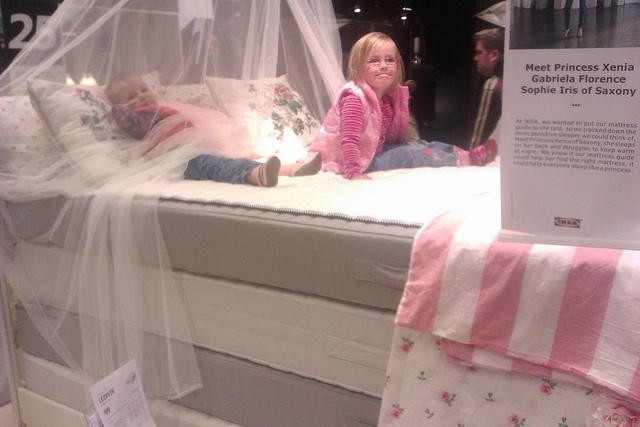How many people are on the bed?
Give a very brief answer. 2. How many people can be seen?
Give a very brief answer. 3. 